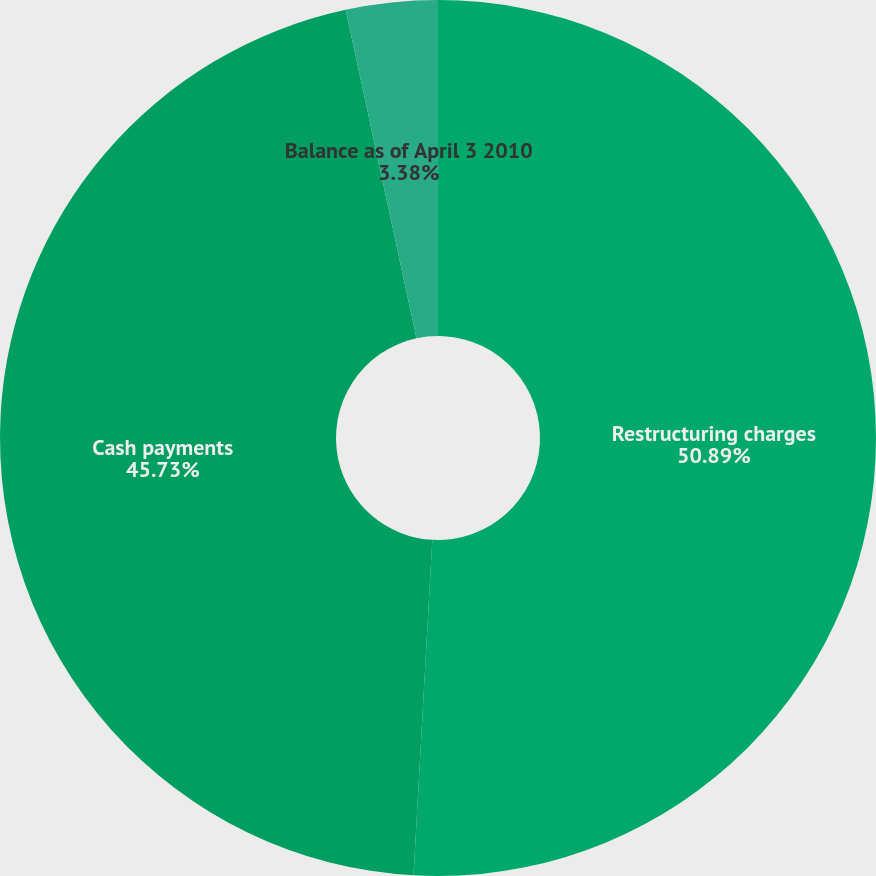Convert chart. <chart><loc_0><loc_0><loc_500><loc_500><pie_chart><fcel>Restructuring charges<fcel>Cash payments<fcel>Balance as of April 3 2010<nl><fcel>50.89%<fcel>45.73%<fcel>3.38%<nl></chart> 